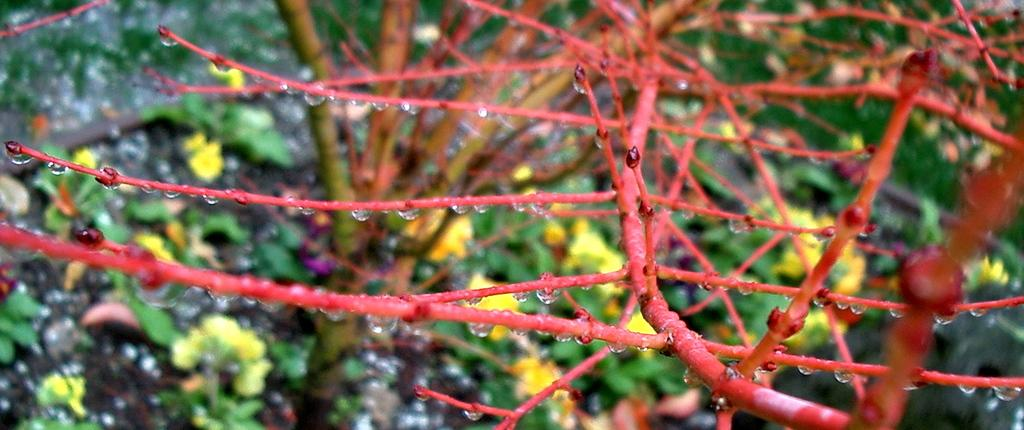What type of living organisms can be seen in the image? Plants can be seen in the image. What specific feature can be observed about the plants in the image? There are yellow color flowers in the image. Absurd Question/Answer: What is the most efficient transport route for the plants in the image? There is no transport route mentioned or implied in the image, as it only features plants with yellow flowers. 